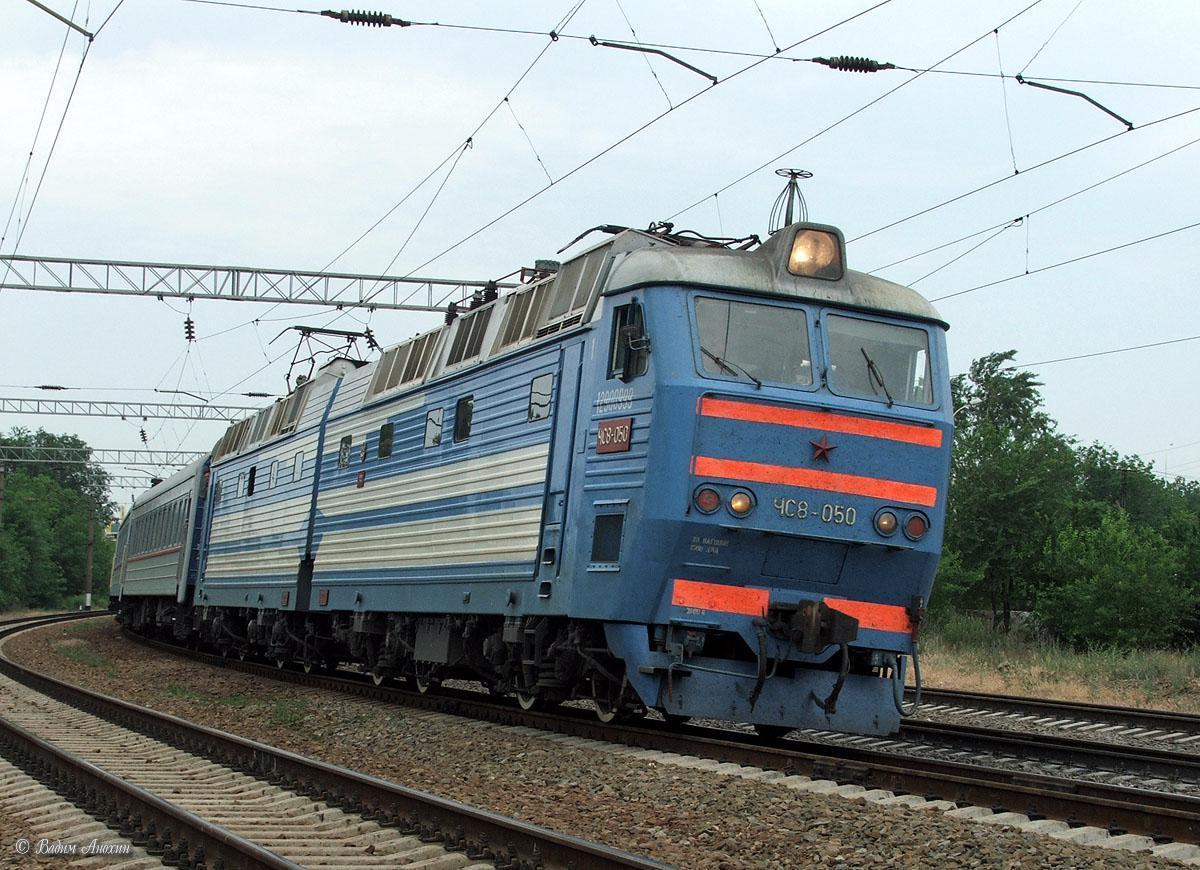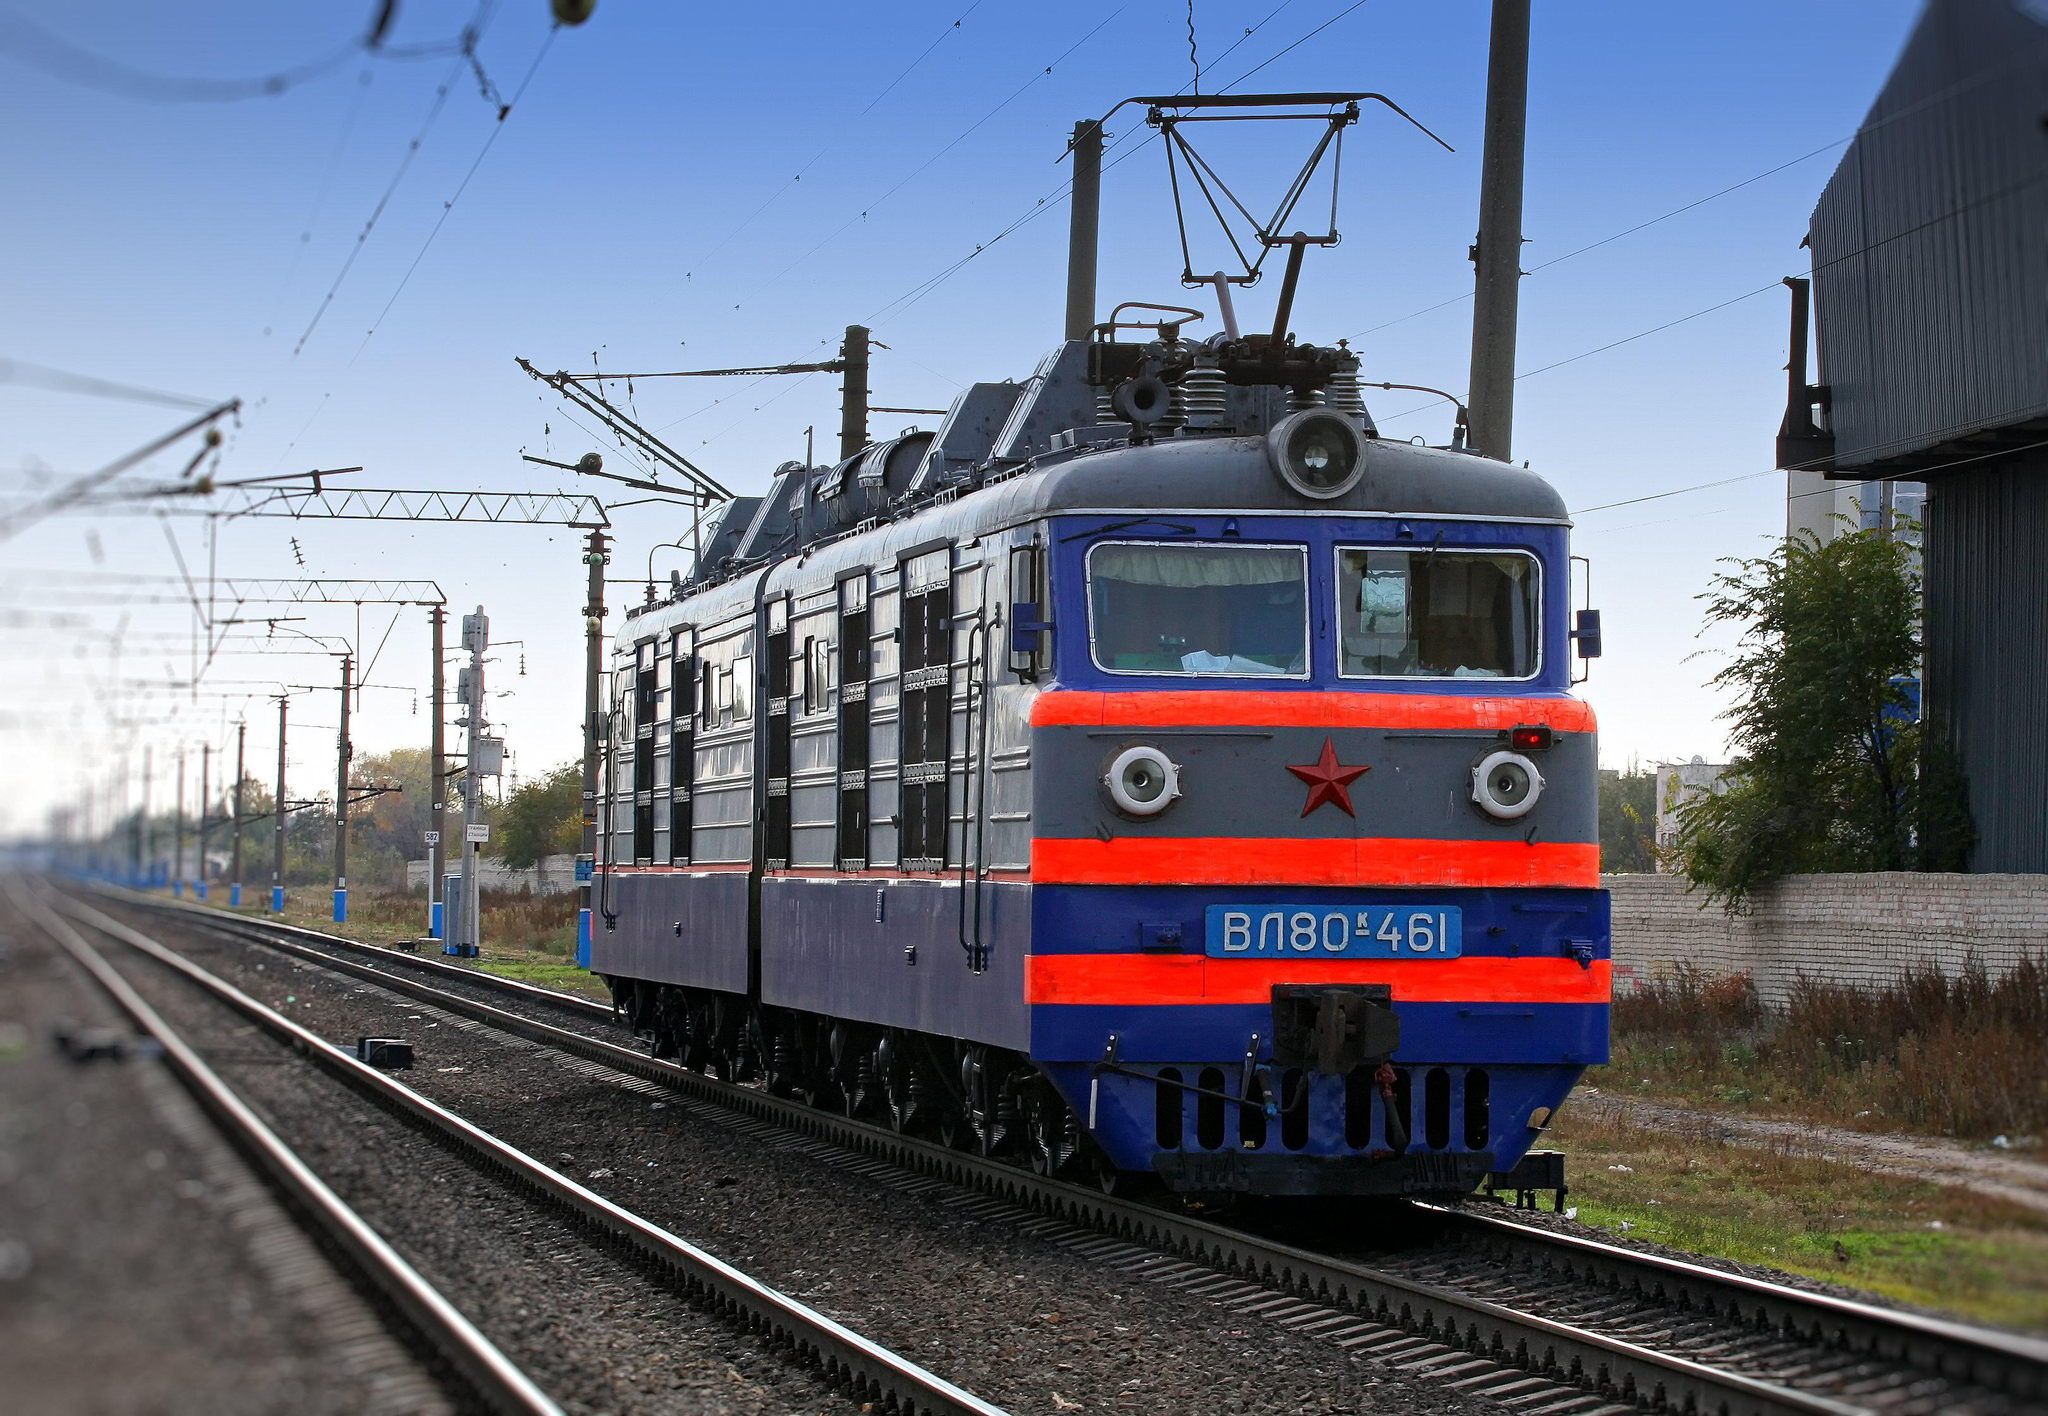The first image is the image on the left, the second image is the image on the right. For the images displayed, is the sentence "Both trains are facing left" factually correct? Answer yes or no. No. 